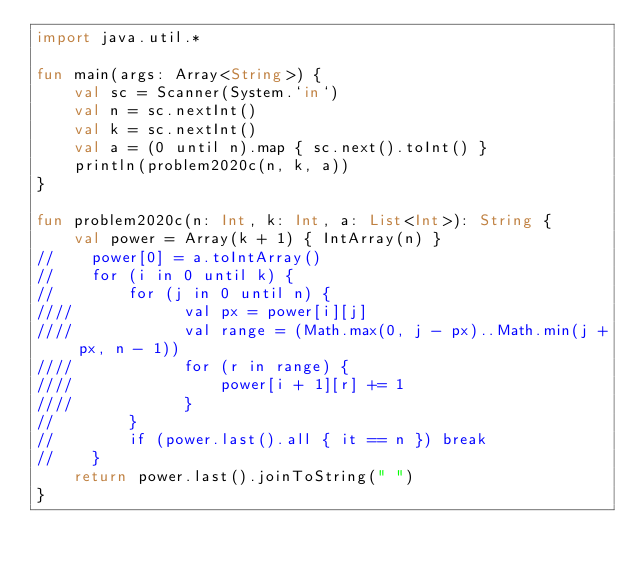<code> <loc_0><loc_0><loc_500><loc_500><_Kotlin_>import java.util.*

fun main(args: Array<String>) {
    val sc = Scanner(System.`in`)
    val n = sc.nextInt()
    val k = sc.nextInt()
    val a = (0 until n).map { sc.next().toInt() }
    println(problem2020c(n, k, a))
}

fun problem2020c(n: Int, k: Int, a: List<Int>): String {
    val power = Array(k + 1) { IntArray(n) }
//    power[0] = a.toIntArray()
//    for (i in 0 until k) {
//        for (j in 0 until n) {
////            val px = power[i][j]
////            val range = (Math.max(0, j - px)..Math.min(j + px, n - 1))
////            for (r in range) {
////                power[i + 1][r] += 1
////            }
//        }
//        if (power.last().all { it == n }) break
//    }
    return power.last().joinToString(" ")
}</code> 